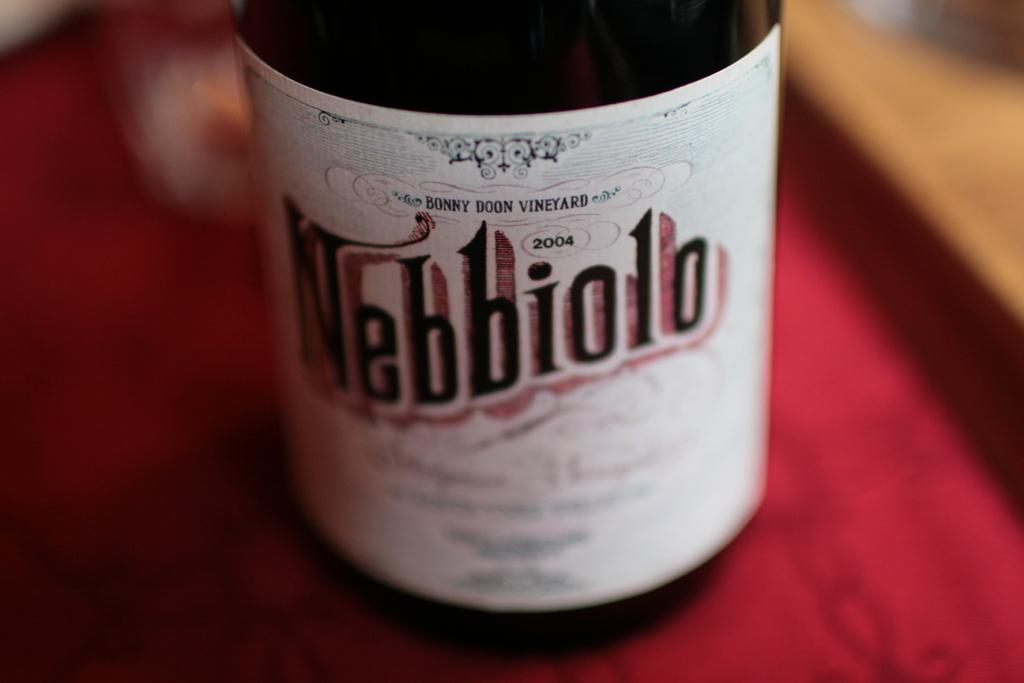<image>
Relay a brief, clear account of the picture shown. Wine Bottle that has the text Nebbiolo on the front of the label, from Bonny Doon Vineyard 2004. 